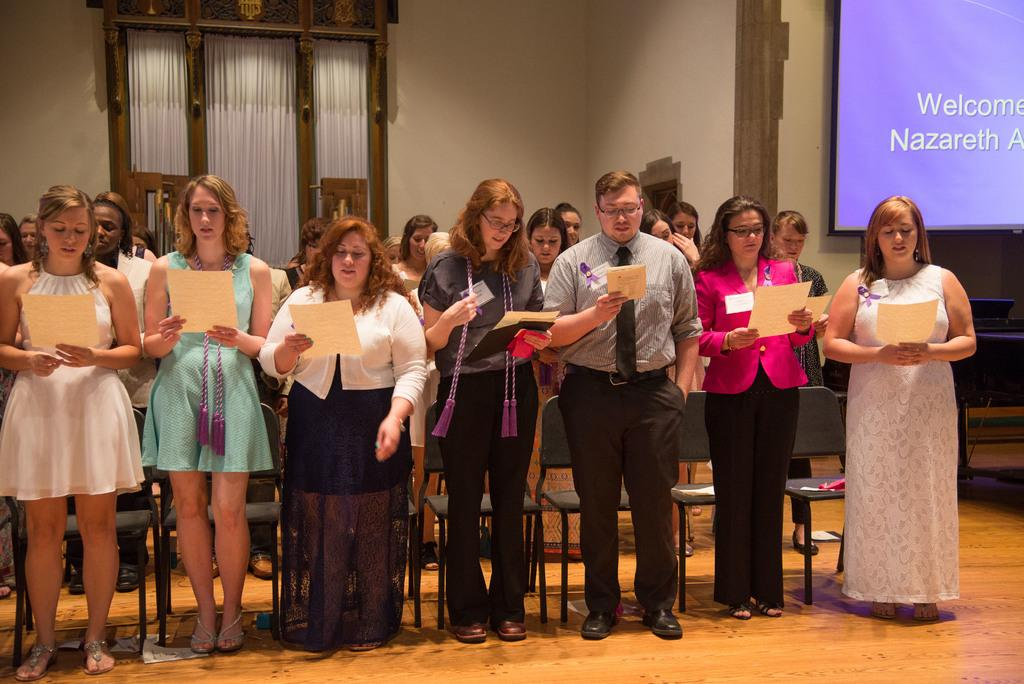What are the people in the image doing? The people in the image are standing on the floor. What are the people near in the image? The people are standing near chairs. What are the people holding in their hands? The people are holding papers in their hands. What can be seen in the background of the image? There is a wall, curtains, a screen, and other objects visible in the background. What type of tail can be seen on the people in the image? There are no tails visible on the people in the image. Can you tell me how many cherries are on the screen in the background? There are no cherries present on the screen in the background. 